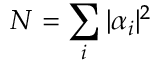Convert formula to latex. <formula><loc_0><loc_0><loc_500><loc_500>N = \sum _ { i } | \alpha _ { i } | ^ { 2 }</formula> 